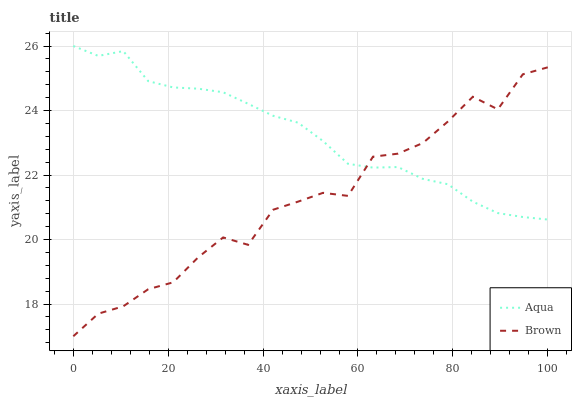Does Brown have the minimum area under the curve?
Answer yes or no. Yes. Does Aqua have the maximum area under the curve?
Answer yes or no. Yes. Does Aqua have the minimum area under the curve?
Answer yes or no. No. Is Aqua the smoothest?
Answer yes or no. Yes. Is Brown the roughest?
Answer yes or no. Yes. Is Aqua the roughest?
Answer yes or no. No. Does Brown have the lowest value?
Answer yes or no. Yes. Does Aqua have the lowest value?
Answer yes or no. No. Does Aqua have the highest value?
Answer yes or no. Yes. Does Aqua intersect Brown?
Answer yes or no. Yes. Is Aqua less than Brown?
Answer yes or no. No. Is Aqua greater than Brown?
Answer yes or no. No. 